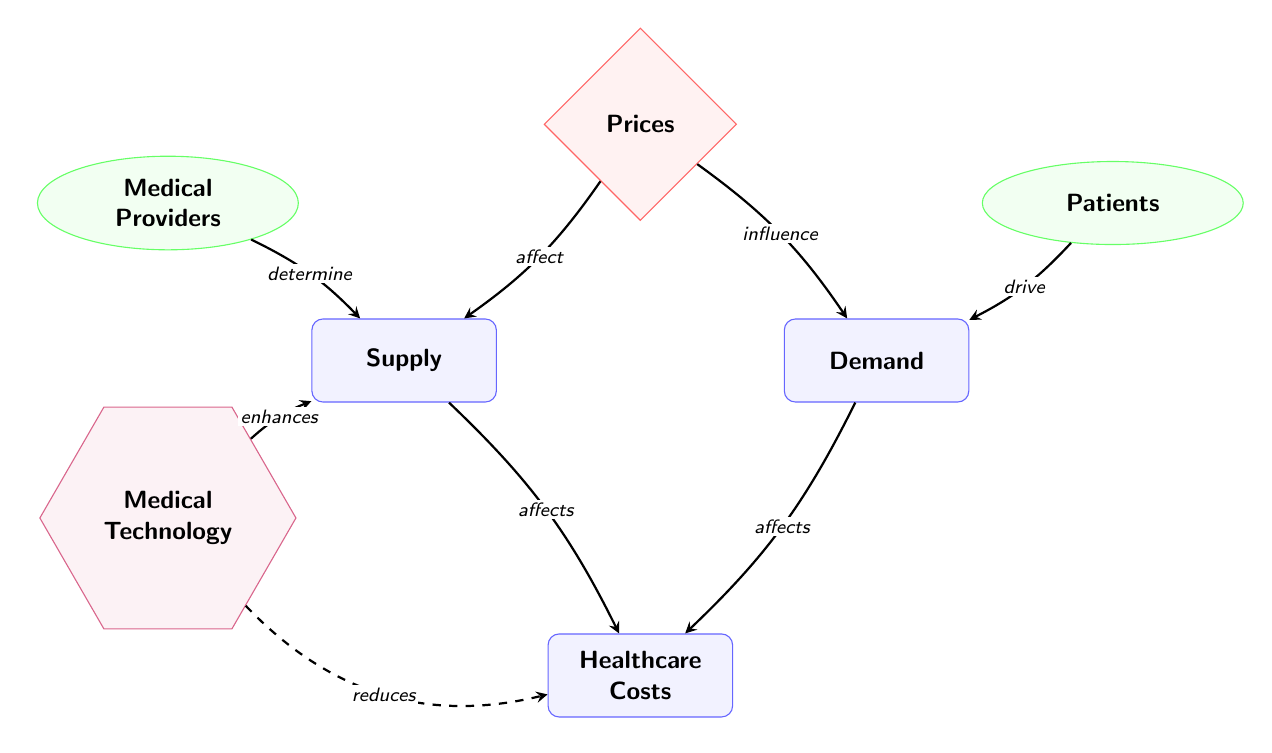What are the two main entities that affect healthcare costs? The diagram shows two arrows pointing towards the "Healthcare Costs" node from the "Supply" and "Demand" nodes, indicating that both entities adversely influence healthcare costs.
Answer: Supply and Demand Who drives demand in the healthcare market? The diagram identifies "Patients" as an actor that has an arrow directed towards the "Demand" node, indicating that they indeed drive demand for healthcare services.
Answer: Patients How does medical technology impact supply? An arrow from "Medical Technology" points to the "Supply" node, indicating that it enhances the supply of healthcare services.
Answer: Enhances What influences demand according to this diagram? The diagram shows an arrow from "Prices" to "Demand," indicating that prices have an influence on the demand for healthcare services.
Answer: Prices Which actor determines supply? The "Medical Providers" actor has an arrow directed towards the "Supply" node, indicating that they are the ones who determine the supply of healthcare services.
Answer: Medical Providers What is the indirect effect of medical technology on healthcare costs? The diagram illustrates an indirect arrow from "Medical Technology" to "Healthcare Costs," labeled "reduces," suggesting that while technology enhances supply, it also indirectly reduces healthcare costs.
Answer: Reduces How many main nodes are present in the diagram? The main nodes consist of "Supply," "Demand," and "Healthcare Costs," which brings the total to three main nodes within the diagram.
Answer: Three What is the relationship between prices and supply? The diagram indicates an arrow from "Prices" to "Supply," labeled "affect," which demonstrates that supply is influenced by the prices in the healthcare market.
Answer: Affect What type of diagram is this? Based on its content and layout, this is a Biomedical Diagram, which illustrates the relationships among different components impacting healthcare costs.
Answer: Biomedical Diagram 